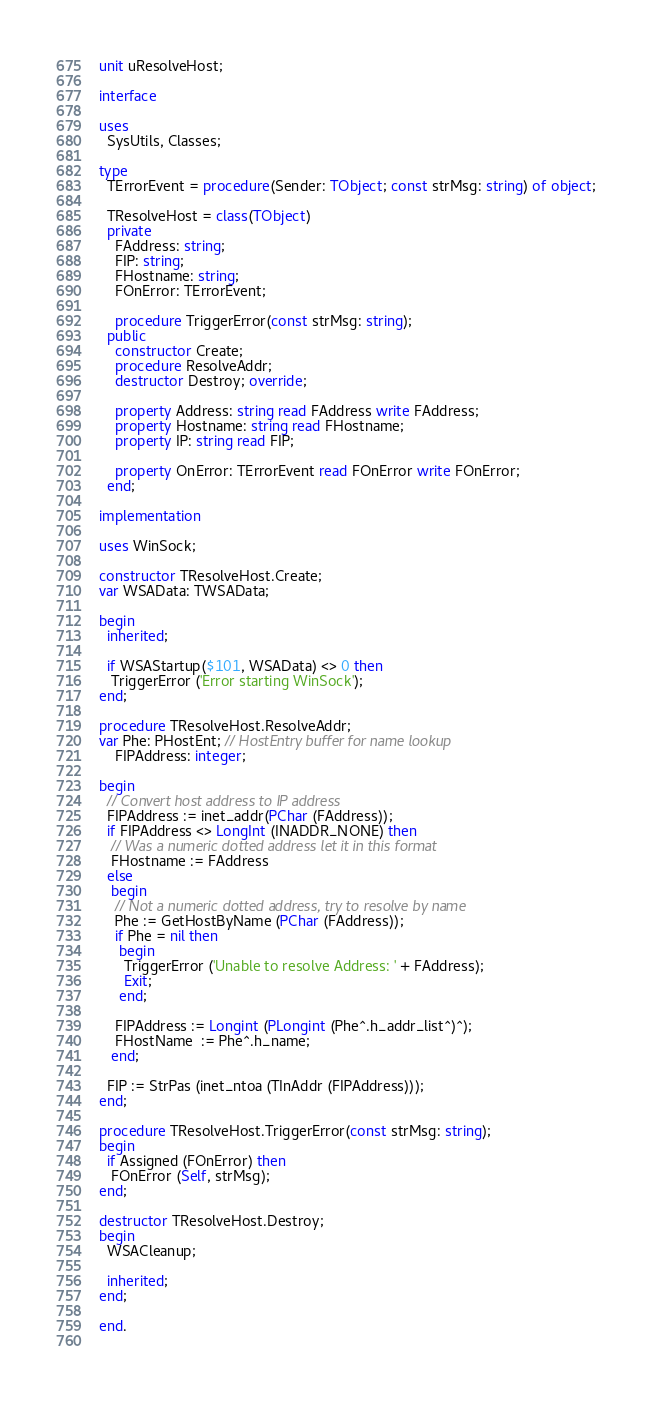<code> <loc_0><loc_0><loc_500><loc_500><_Pascal_>unit uResolveHost;

interface

uses
  SysUtils, Classes;

type
  TErrorEvent = procedure(Sender: TObject; const strMsg: string) of object;

  TResolveHost = class(TObject)
  private
    FAddress: string;
    FIP: string;
    FHostname: string;
    FOnError: TErrorEvent;

    procedure TriggerError(const strMsg: string);
  public
    constructor Create;
    procedure ResolveAddr;
    destructor Destroy; override;

    property Address: string read FAddress write FAddress;
    property Hostname: string read FHostname;
    property IP: string read FIP;

    property OnError: TErrorEvent read FOnError write FOnError;
  end;

implementation

uses WinSock;

constructor TResolveHost.Create;
var WSAData: TWSAData;

begin
  inherited;

  if WSAStartup($101, WSAData) <> 0 then
   TriggerError ('Error starting WinSock');
end;

procedure TResolveHost.ResolveAddr;
var Phe: PHostEnt; // HostEntry buffer for name lookup
    FIPAddress: integer;

begin
  // Convert host address to IP address
  FIPAddress := inet_addr(PChar (FAddress));
  if FIPAddress <> LongInt (INADDR_NONE) then
   // Was a numeric dotted address let it in this format
   FHostname := FAddress
  else
   begin
    // Not a numeric dotted address, try to resolve by name
    Phe := GetHostByName (PChar (FAddress));
    if Phe = nil then
     begin
      TriggerError ('Unable to resolve Address: ' + FAddress);
      Exit;
     end;

    FIPAddress := Longint (PLongint (Phe^.h_addr_list^)^);
    FHostName  := Phe^.h_name;
   end;

  FIP := StrPas (inet_ntoa (TInAddr (FIPAddress)));
end;

procedure TResolveHost.TriggerError(const strMsg: string);
begin
  if Assigned (FOnError) then
   FOnError (Self, strMsg);
end;

destructor TResolveHost.Destroy;
begin
  WSACleanup;

  inherited;
end;

end.
 </code> 